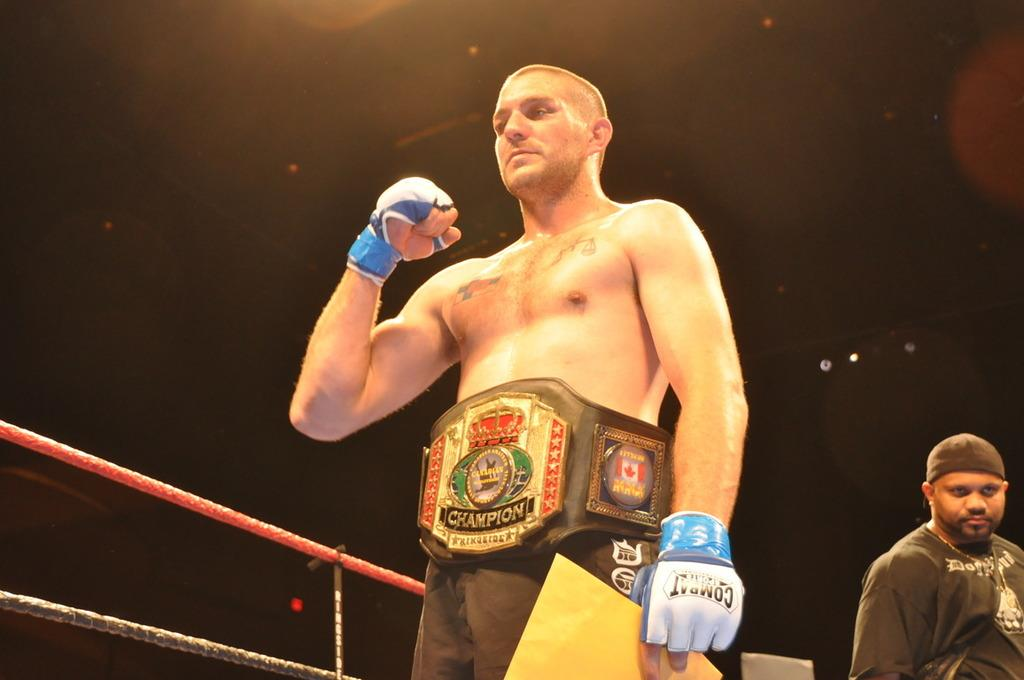What is the person wearing in the image? The person is wearing a belt in the image. What is the person holding in the image? The person is holding something in the image. How many people are present in the image? There are two people in the image. What type of produce can be seen growing in the image? There is no produce visible in the image. How does the person wearing a belt fall in the image? The person wearing a belt does not fall in the image; they are standing or holding something. 